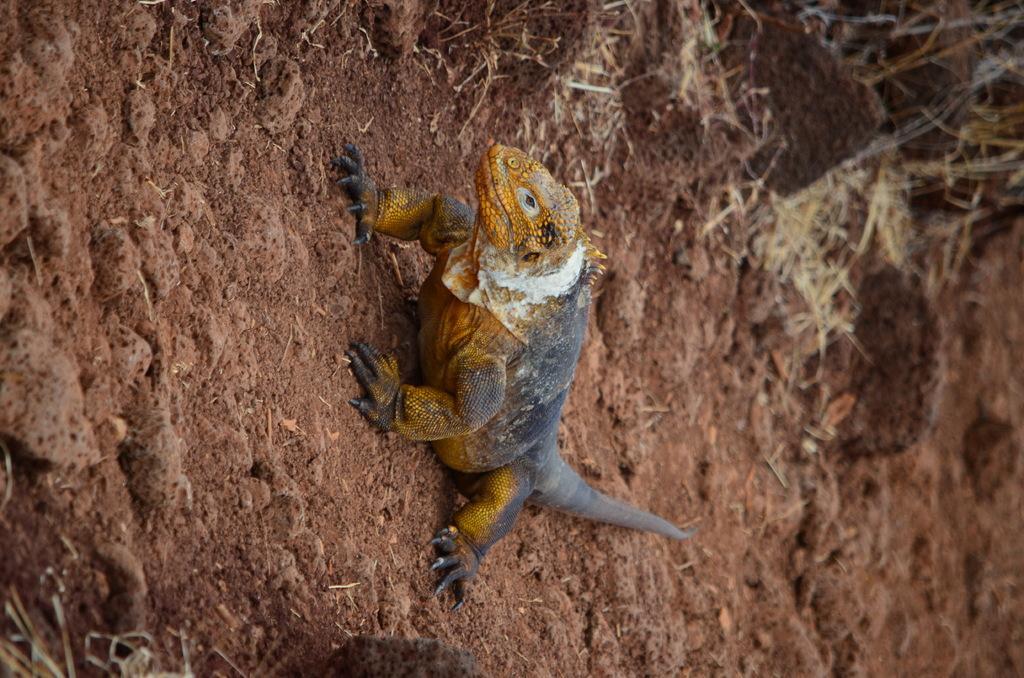How would you summarize this image in a sentence or two? In this image I see a lizard over here which is of yellow, black and white in color and it is on the mud and I see the grass. 